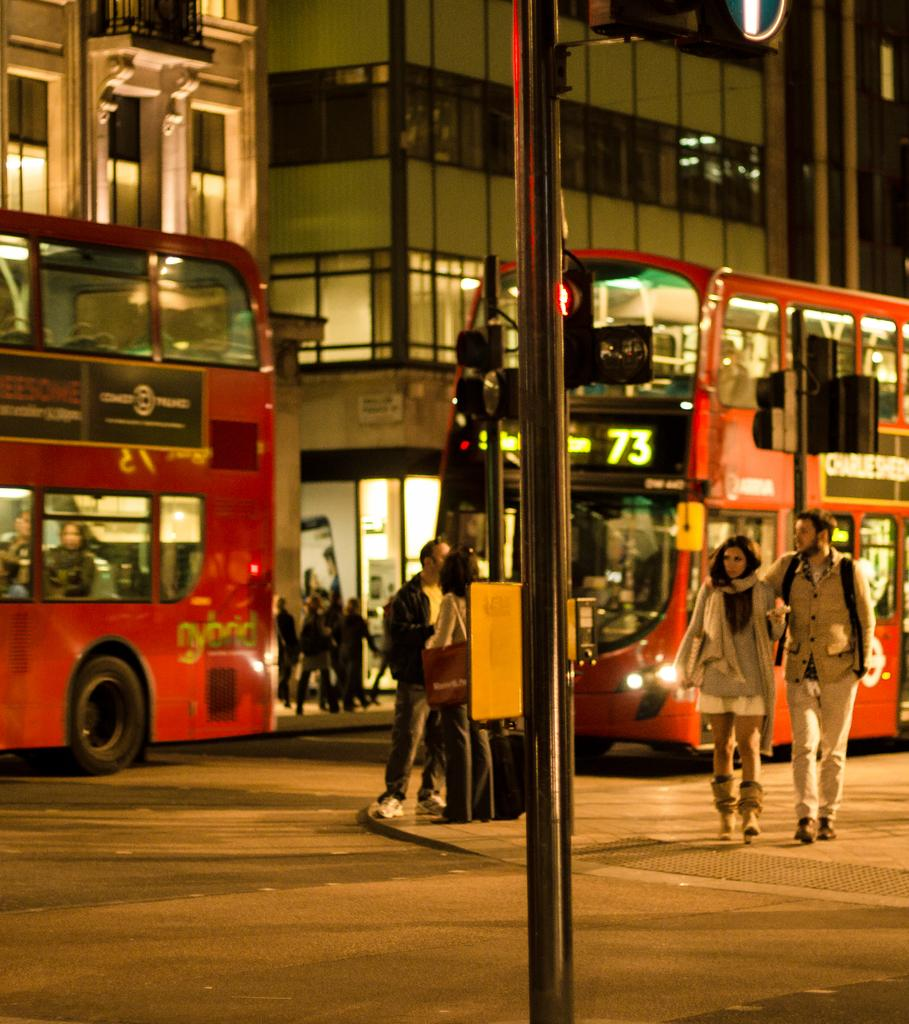What type of vehicles can be seen on the road in the image? There are buses on the road in the image. Can you identify any living beings in the image? Yes, there are people visible in the image. What is the color of the pole in the image? The pole in the image is black. What type of buildings can be seen in the background? There are buildings with glass windows in the background. What type of hole can be seen in the image? There is no hole present in the image. What part of the human body is visible in the image? There is no specific part of the human body visible in the image; only people in general can be seen. 